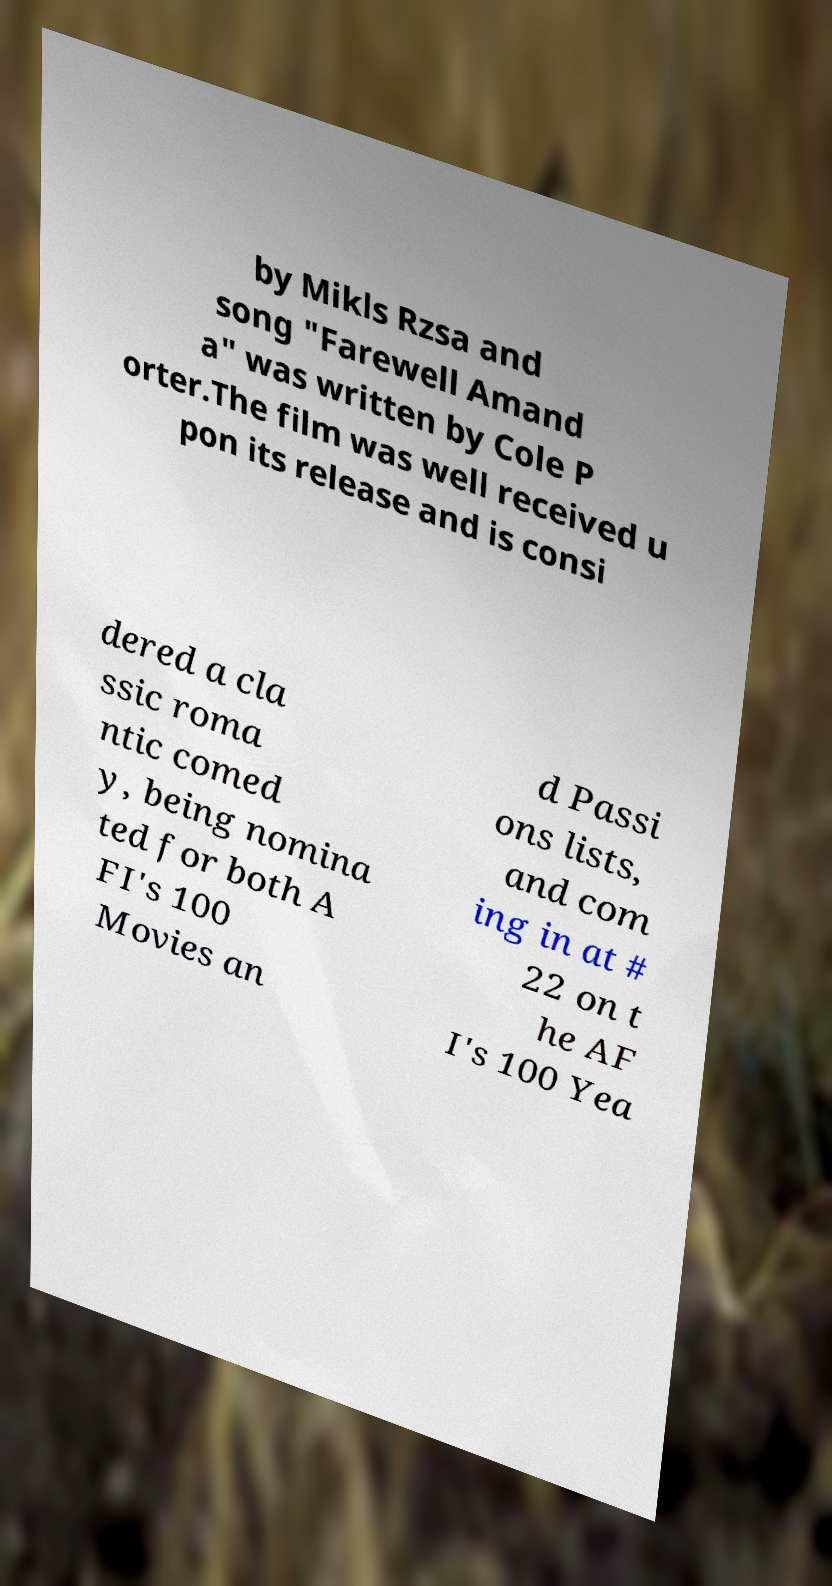Can you accurately transcribe the text from the provided image for me? by Mikls Rzsa and song "Farewell Amand a" was written by Cole P orter.The film was well received u pon its release and is consi dered a cla ssic roma ntic comed y, being nomina ted for both A FI's 100 Movies an d Passi ons lists, and com ing in at # 22 on t he AF I's 100 Yea 